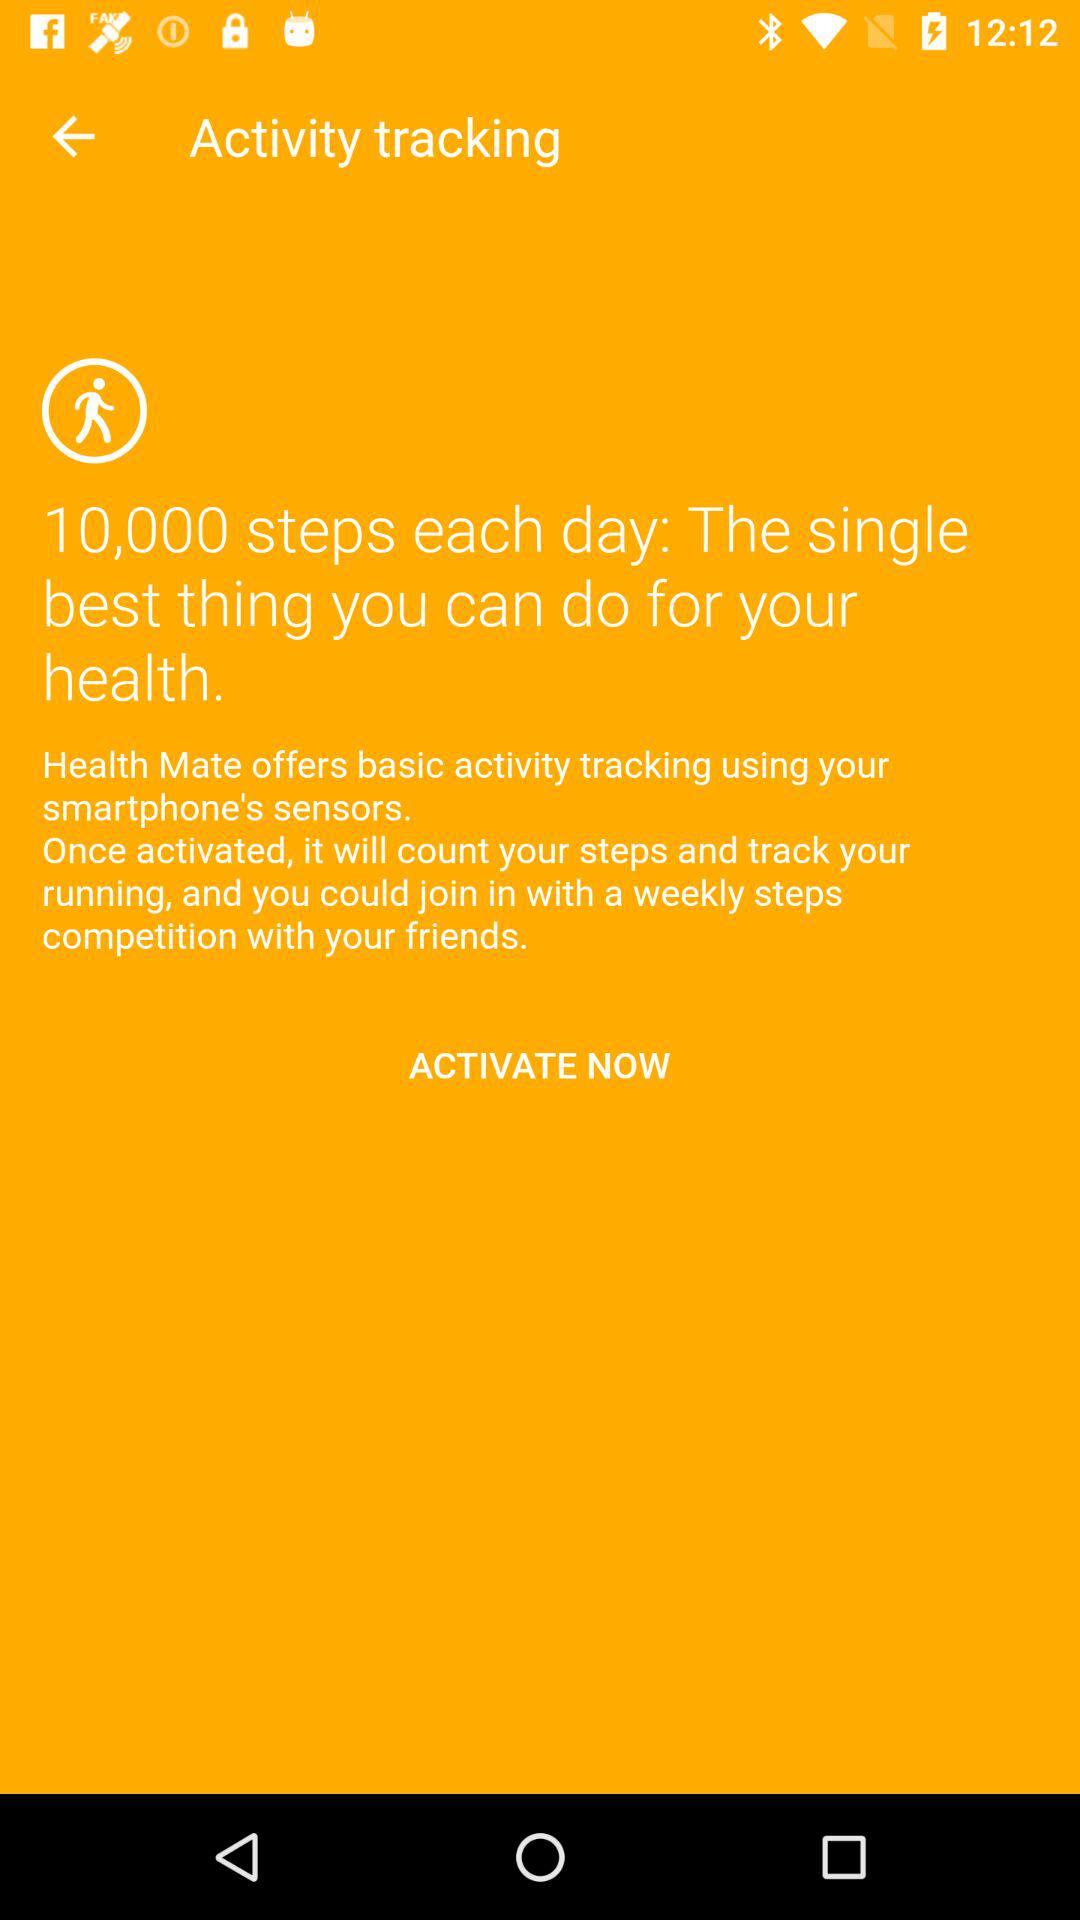How many steps are there for each day? There are 10,000 steps for each day. 